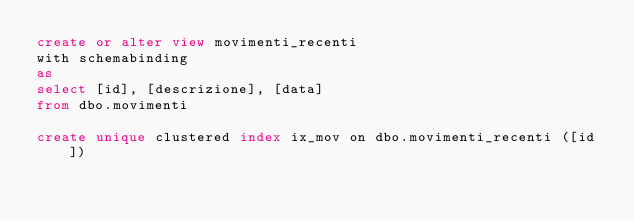Convert code to text. <code><loc_0><loc_0><loc_500><loc_500><_SQL_>create or alter view movimenti_recenti
with schemabinding
as
select [id], [descrizione], [data]
from dbo.movimenti

create unique clustered index ix_mov on dbo.movimenti_recenti ([id])</code> 